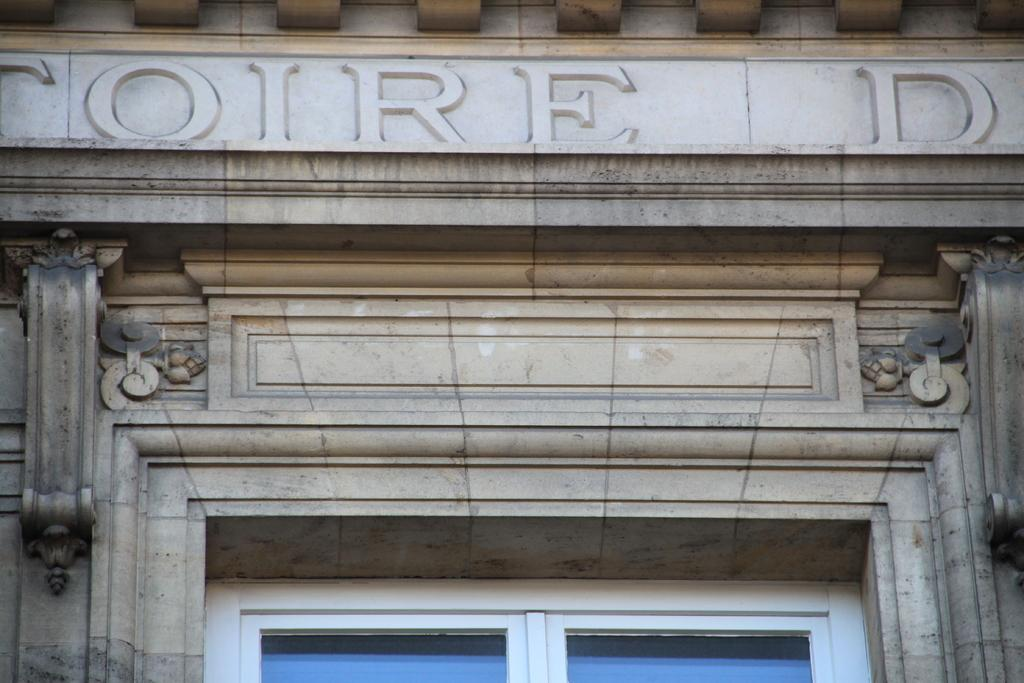What type of structure is visible in the image? There is a building in the image. How many doors can be seen at the bottom of the building? There are two doors at the bottom of the image. How many rabbits can be seen hopping around the building in the image? There are no rabbits visible in the image; it only features a building with two doors. 